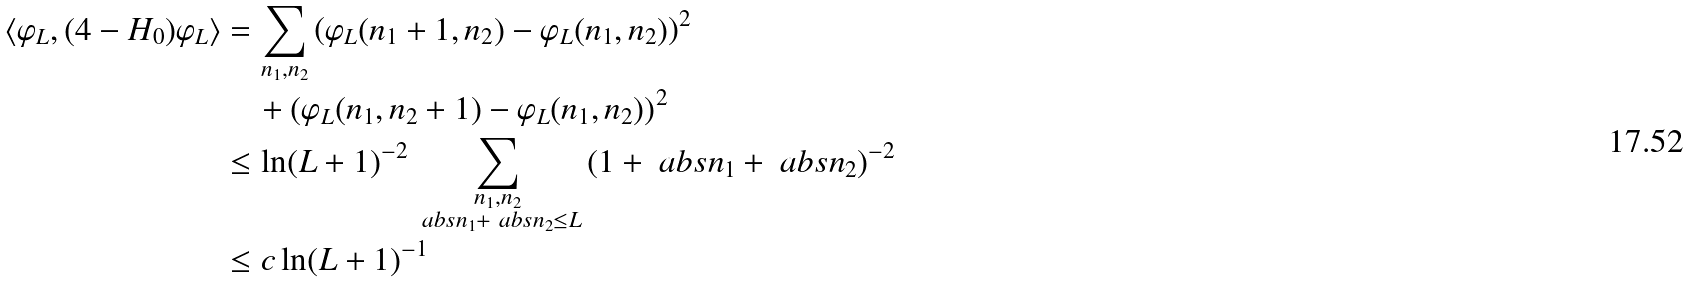<formula> <loc_0><loc_0><loc_500><loc_500>\langle \varphi _ { L } , ( 4 - H _ { 0 } ) \varphi _ { L } \rangle & = \sum _ { n _ { 1 } , n _ { 2 } } \left ( \varphi _ { L } ( n _ { 1 } + 1 , n _ { 2 } ) - \varphi _ { L } ( n _ { 1 } , n _ { 2 } ) \right ) ^ { 2 } \\ & \quad + \left ( \varphi _ { L } ( n _ { 1 } , n _ { 2 } + 1 ) - \varphi _ { L } ( n _ { 1 } , n _ { 2 } ) \right ) ^ { 2 } \\ & \leq \ln ( L + 1 ) ^ { - 2 } \sum _ { \substack { n _ { 1 } , n _ { 2 } \\ \ a b s { n _ { 1 } } + \ a b s { n _ { 2 } } \leq L } } \, ( 1 + \ a b s { n _ { 1 } } + \ a b s { n _ { 2 } } ) ^ { - 2 } \\ & \leq c \ln ( L + 1 ) ^ { - 1 }</formula> 